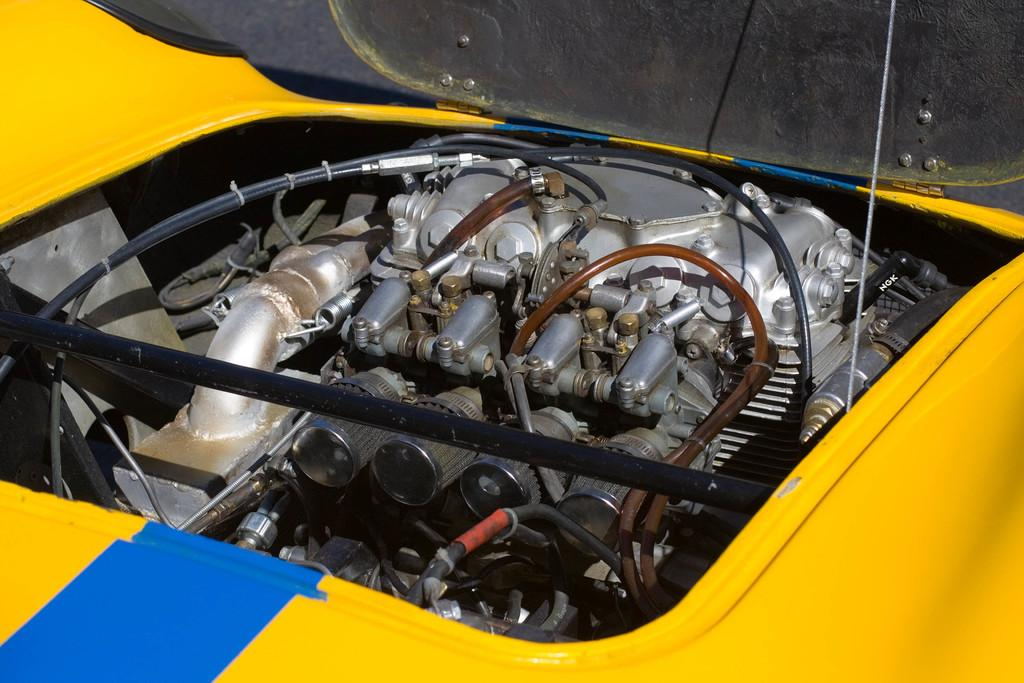What is the main subject of the image? The main subject of the image is an engine. What type of object does the engine belong to? The engine belongs to a vehicle. Where is the print of the engine located in the image? There is no print of the engine in the image; it is a photograph or digital representation of the actual engine. 